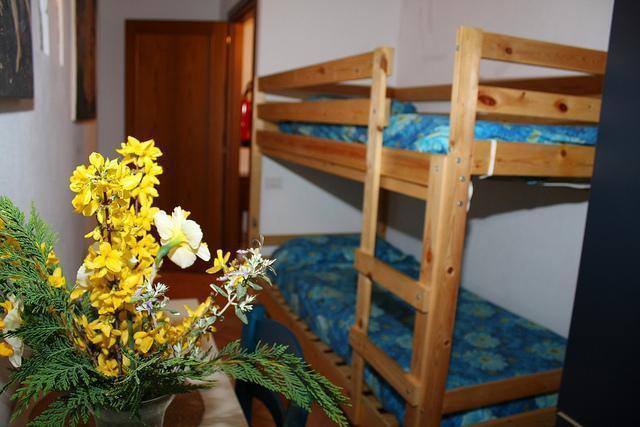What type of bed is shown?
Select the accurate answer and provide explanation: 'Answer: answer
Rationale: rationale.'
Options: Queen, king, air mattress, bunk bed. Answer: bunk bed.
Rationale: There are 2 beds. 